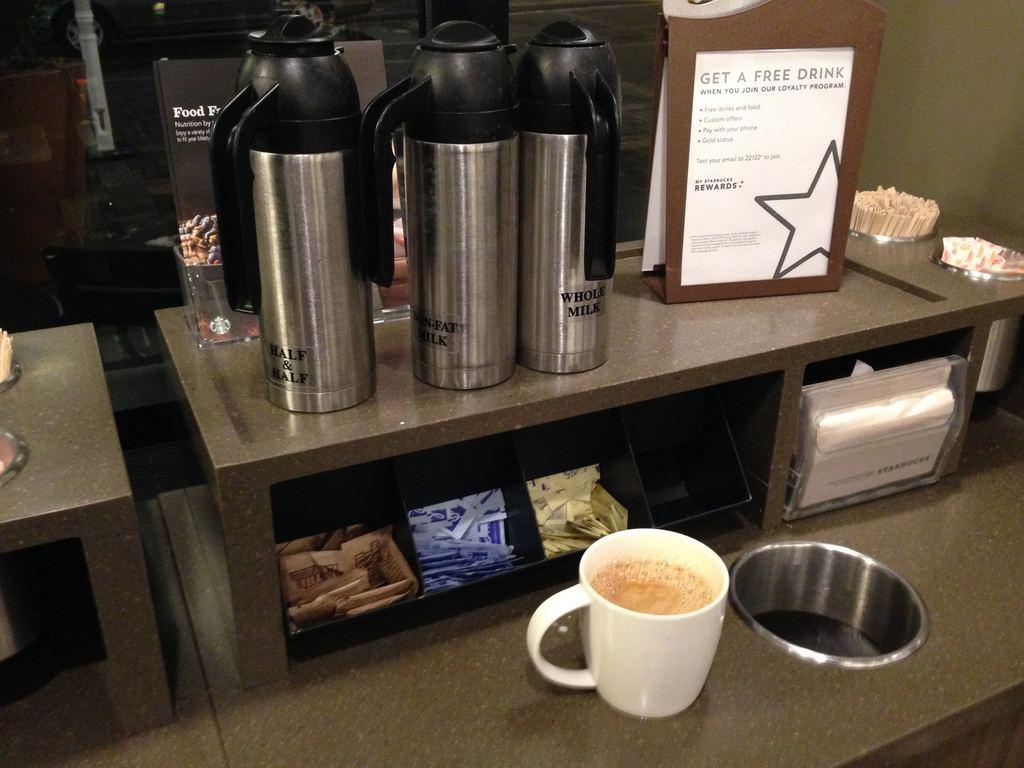<image>
Present a compact description of the photo's key features. A coffee shop that advertises that people can get a free drink when they join the loyalty program. 